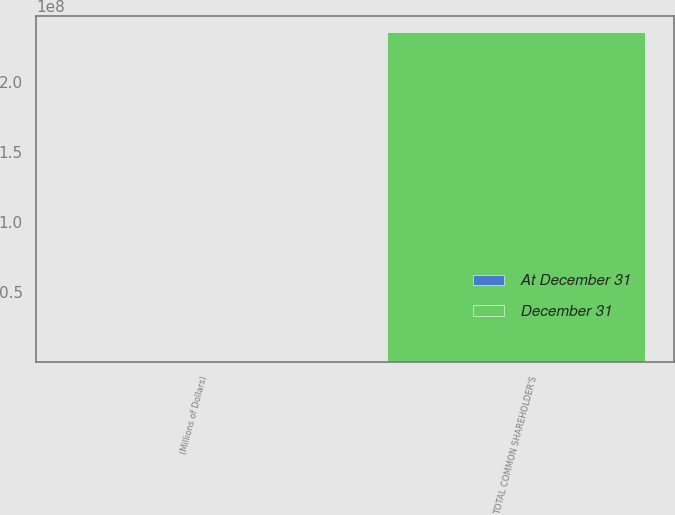<chart> <loc_0><loc_0><loc_500><loc_500><stacked_bar_chart><ecel><fcel>(Millions of Dollars)<fcel>TOTAL COMMON SHAREHOLDER'S<nl><fcel>December 31<fcel>2014<fcel>2.35488e+08<nl><fcel>At December 31<fcel>2014<fcel>11199<nl></chart> 